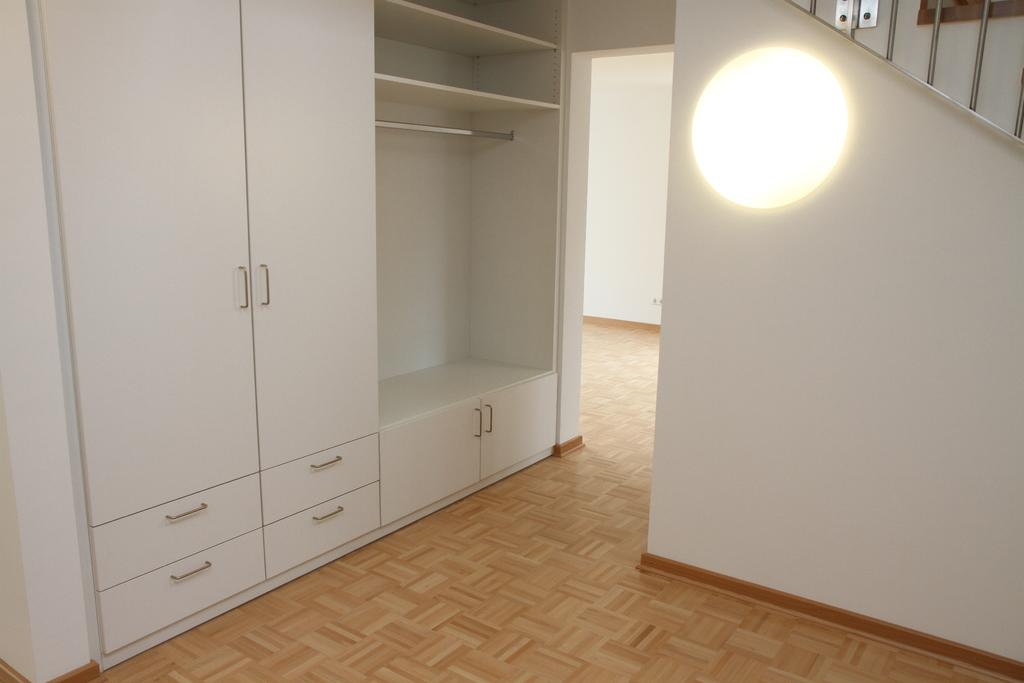What type of furniture is present in the image? There are cupboards in the image. What object can be seen hanging in the image? There is a rod in the image. What surface is visible in the image? The image shows a floor. What can be seen in the background of the image? There is a wall and a light in the background of the image. Can you see any bubbles floating around in the image? There are no bubbles present in the image. What type of shelf is visible in the image? There is no shelf visible in the image; only cupboards, a rod, and a light are present. 